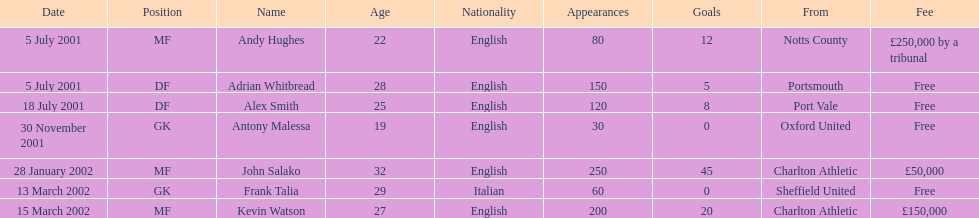Whos name is listed last on the chart? Kevin Watson. 